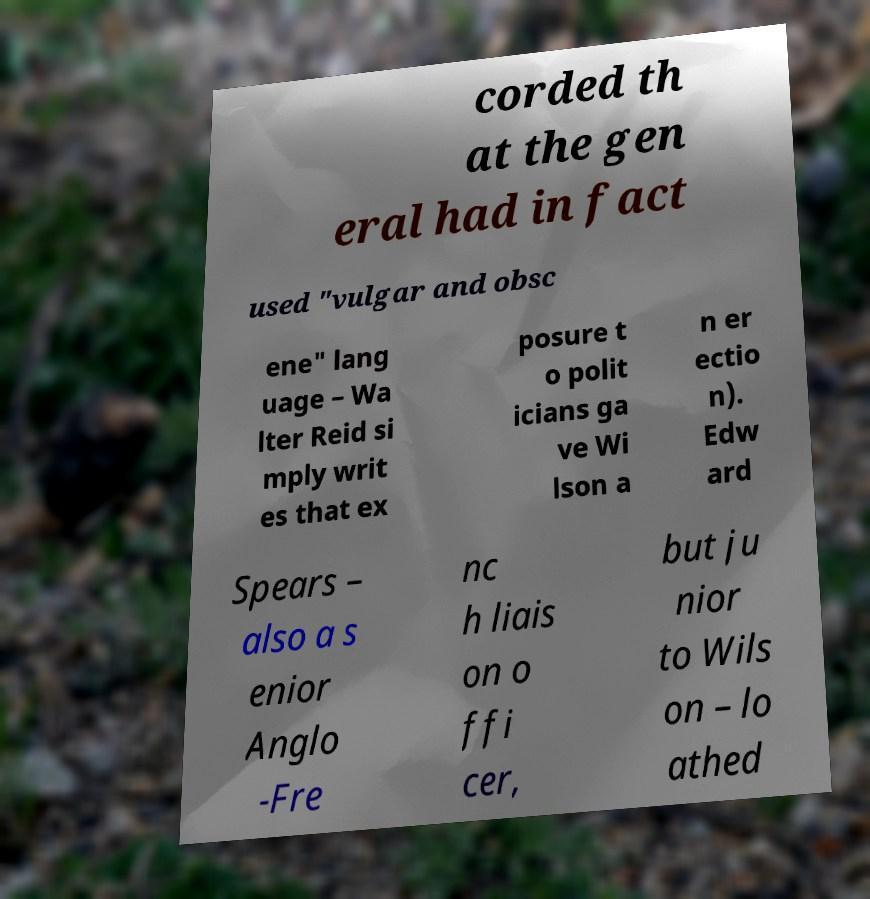For documentation purposes, I need the text within this image transcribed. Could you provide that? corded th at the gen eral had in fact used "vulgar and obsc ene" lang uage – Wa lter Reid si mply writ es that ex posure t o polit icians ga ve Wi lson a n er ectio n). Edw ard Spears – also a s enior Anglo -Fre nc h liais on o ffi cer, but ju nior to Wils on – lo athed 